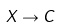<formula> <loc_0><loc_0><loc_500><loc_500>X \to C</formula> 